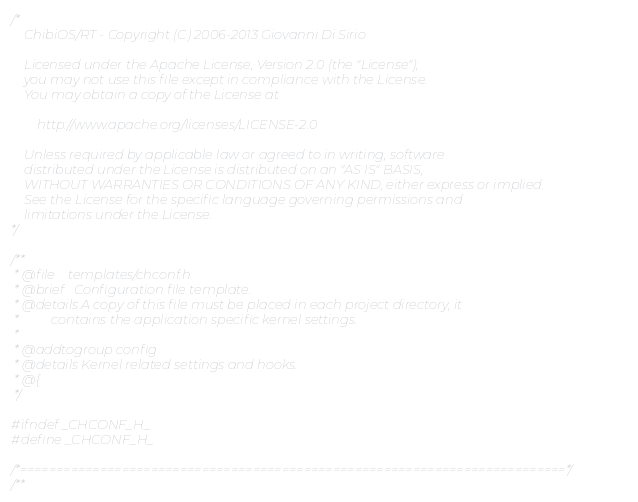<code> <loc_0><loc_0><loc_500><loc_500><_C_>/*
    ChibiOS/RT - Copyright (C) 2006-2013 Giovanni Di Sirio

    Licensed under the Apache License, Version 2.0 (the "License");
    you may not use this file except in compliance with the License.
    You may obtain a copy of the License at

        http://www.apache.org/licenses/LICENSE-2.0

    Unless required by applicable law or agreed to in writing, software
    distributed under the License is distributed on an "AS IS" BASIS,
    WITHOUT WARRANTIES OR CONDITIONS OF ANY KIND, either express or implied.
    See the License for the specific language governing permissions and
    limitations under the License.
*/

/**
 * @file    templates/chconf.h
 * @brief   Configuration file template.
 * @details A copy of this file must be placed in each project directory, it
 *          contains the application specific kernel settings.
 *
 * @addtogroup config
 * @details Kernel related settings and hooks.
 * @{
 */

#ifndef _CHCONF_H_
#define _CHCONF_H_

/*===========================================================================*/
/**</code> 